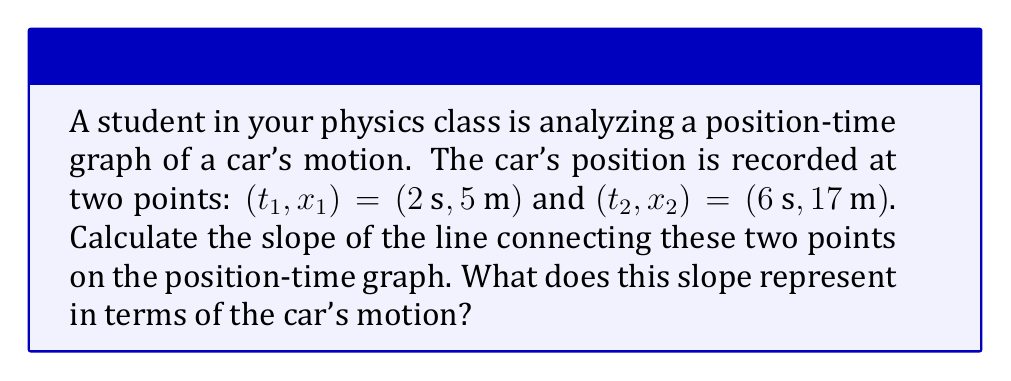Could you help me with this problem? Let's approach this step-by-step:

1) The slope of a line on a position-time graph represents the velocity of the object. We can calculate it using the formula:

   $$\text{slope} = \frac{\Delta x}{\Delta t} = \frac{x_2 - x_1}{t_2 - t_1}$$

2) We have the following points:
   $(t_1, x_1) = (2\text{ s}, 5\text{ m})$
   $(t_2, x_2) = (6\text{ s}, 17\text{ m})$

3) Let's substitute these values into our formula:

   $$\text{slope} = \frac{17\text{ m} - 5\text{ m}}{6\text{ s} - 2\text{ s}}$$

4) Simplify:
   $$\text{slope} = \frac{12\text{ m}}{4\text{ s}}$$

5) Divide:
   $$\text{slope} = 3\text{ m/s}$$

6) The slope of the line is 3 m/s. In the context of a position-time graph, this represents the average velocity of the car between these two points in time.
Answer: $3\text{ m/s}$, representing the car's average velocity 